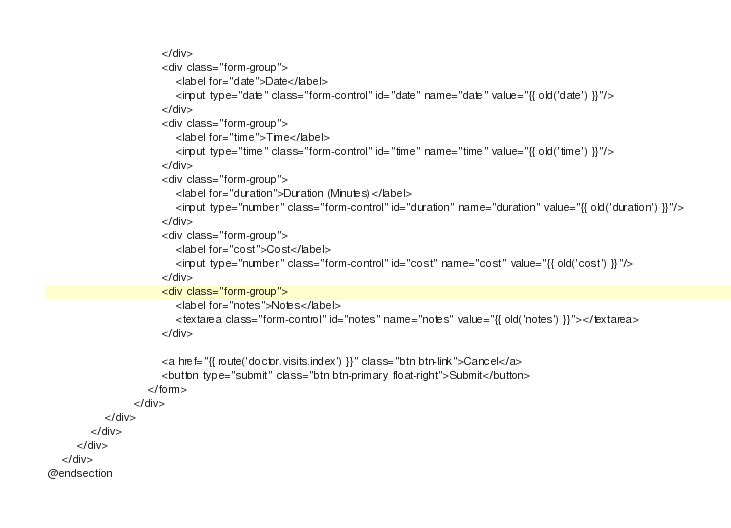<code> <loc_0><loc_0><loc_500><loc_500><_PHP_>                                </div>
                                <div class="form-group">
                                    <label for="date">Date</label>
                                    <input type="date" class="form-control" id="date" name="date" value="{{ old('date') }}"/>
                                </div>
                                <div class="form-group">
                                    <label for="time">Time</label>
                                    <input type="time" class="form-control" id="time" name="time" value="{{ old('time') }}"/>
                                </div>
                                <div class="form-group">
                                    <label for="duration">Duration (Minutes)</label>
                                    <input type="number" class="form-control" id="duration" name="duration" value="{{ old('duration') }}"/>
                                </div>
                                <div class="form-group">
                                    <label for="cost">Cost</label>
                                    <input type="number" class="form-control" id="cost" name="cost" value="{{ old('cost') }}"/>
                                </div>
                                <div class="form-group">
                                    <label for="notes">Notes</label>
                                    <textarea class="form-control" id="notes" name="notes" value="{{ old('notes') }}"></textarea>
                                </div>

                                <a href="{{ route('doctor.visits.index') }}" class="btn btn-link">Cancel</a>
                                <button type="submit" class="btn btn-primary float-right">Submit</button>
                            </form>
                        </div>
                </div>
            </div>
        </div>
    </div>
@endsection</code> 